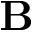Convert formula to latex. <formula><loc_0><loc_0><loc_500><loc_500>B</formula> 